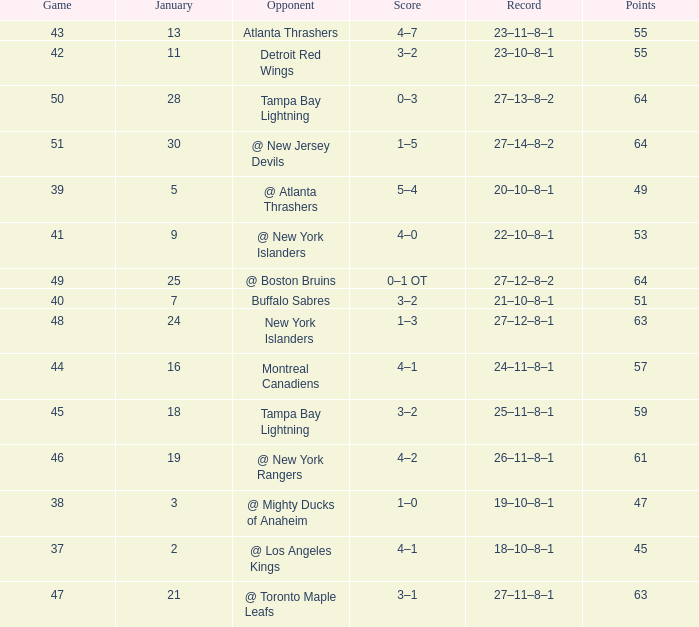Which Score has Points of 64, and a Game of 49? 0–1 OT. 